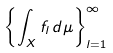<formula> <loc_0><loc_0><loc_500><loc_500>\left \{ \int _ { X } f _ { l } \, d \mu \right \} _ { l = 1 } ^ { \infty }</formula> 